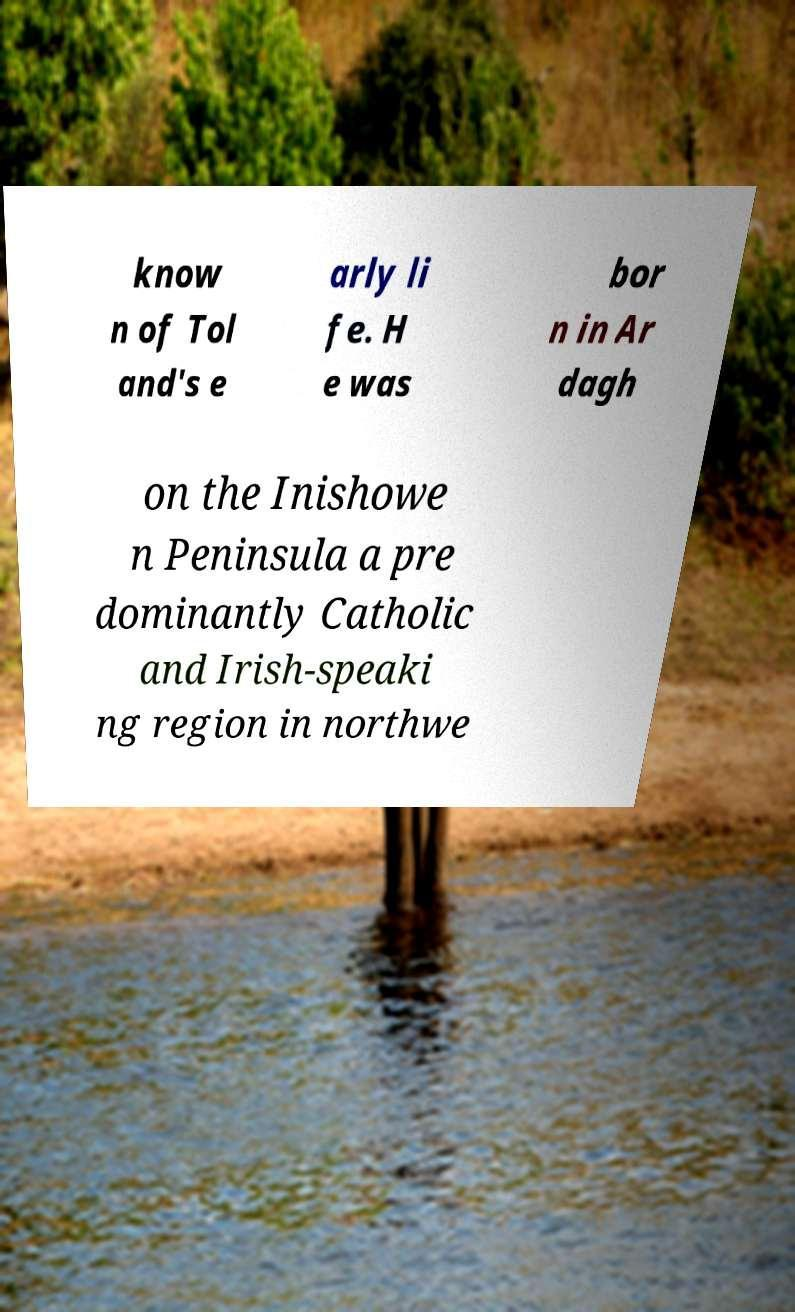Could you extract and type out the text from this image? know n of Tol and's e arly li fe. H e was bor n in Ar dagh on the Inishowe n Peninsula a pre dominantly Catholic and Irish-speaki ng region in northwe 